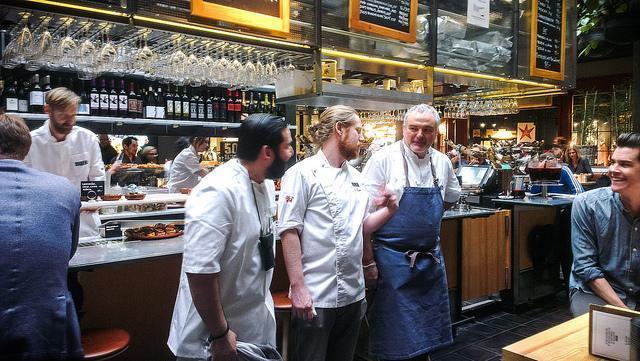What profession are the men wearing aprons?
Select the accurate answer and provide explanation: 'Answer: answer
Rationale: rationale.'
Options: Janitors, artists, cooks, repairmen. Answer: cooks.
Rationale: The people are cooks in a restaurant. 